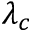Convert formula to latex. <formula><loc_0><loc_0><loc_500><loc_500>\lambda _ { c }</formula> 